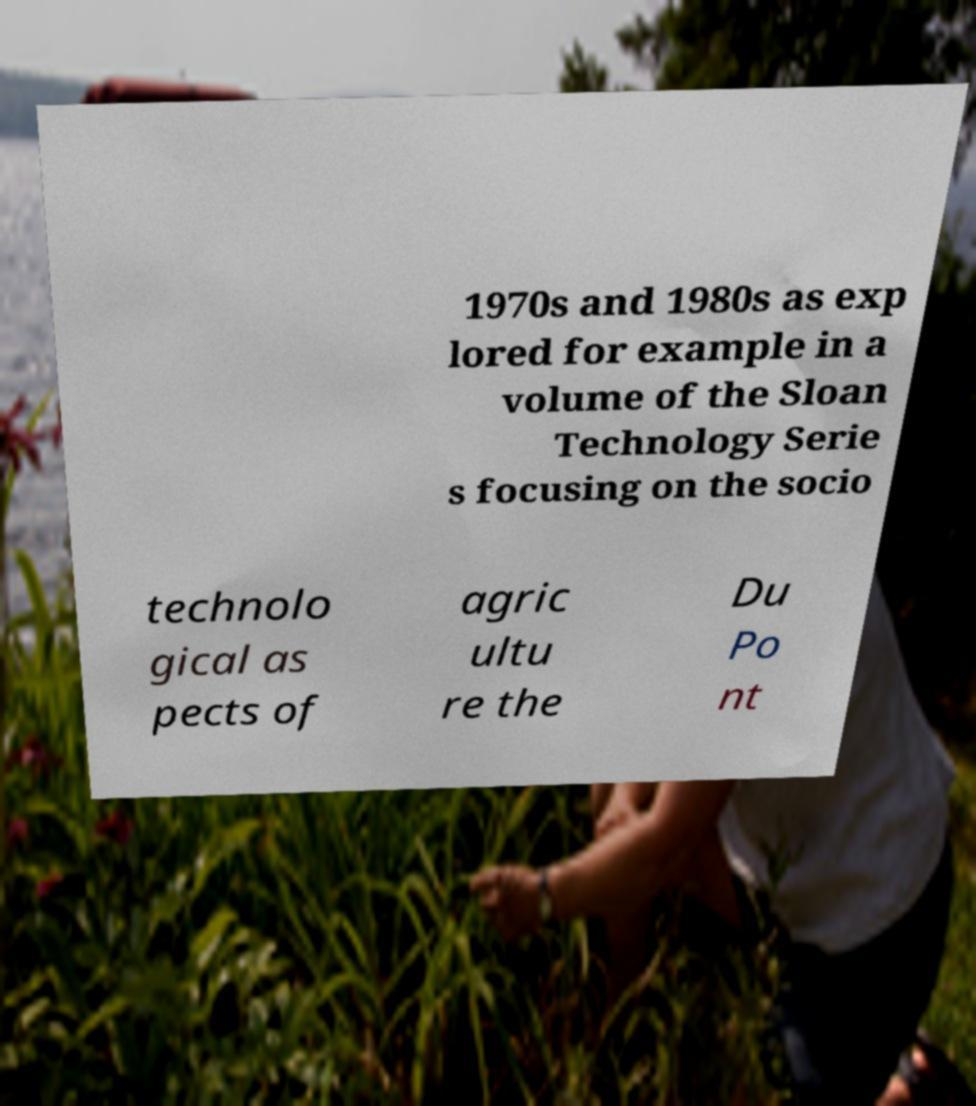Can you read and provide the text displayed in the image?This photo seems to have some interesting text. Can you extract and type it out for me? 1970s and 1980s as exp lored for example in a volume of the Sloan Technology Serie s focusing on the socio technolo gical as pects of agric ultu re the Du Po nt 